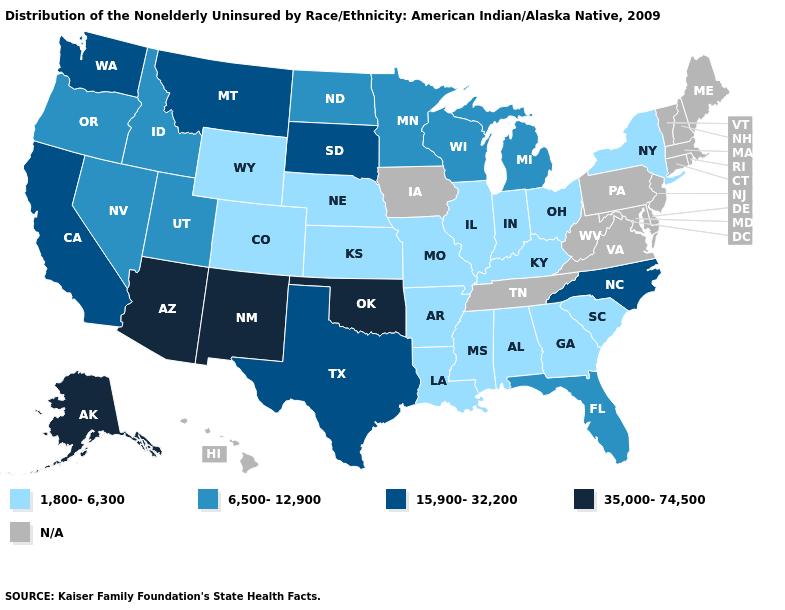Among the states that border Virginia , does Kentucky have the highest value?
Give a very brief answer. No. Name the states that have a value in the range 15,900-32,200?
Be succinct. California, Montana, North Carolina, South Dakota, Texas, Washington. Name the states that have a value in the range 15,900-32,200?
Be succinct. California, Montana, North Carolina, South Dakota, Texas, Washington. Among the states that border South Dakota , which have the lowest value?
Keep it brief. Nebraska, Wyoming. What is the value of Louisiana?
Quick response, please. 1,800-6,300. What is the value of Arizona?
Keep it brief. 35,000-74,500. What is the lowest value in the USA?
Write a very short answer. 1,800-6,300. Does the map have missing data?
Answer briefly. Yes. Name the states that have a value in the range 35,000-74,500?
Give a very brief answer. Alaska, Arizona, New Mexico, Oklahoma. Name the states that have a value in the range 35,000-74,500?
Answer briefly. Alaska, Arizona, New Mexico, Oklahoma. What is the value of Delaware?
Short answer required. N/A. Which states have the lowest value in the USA?
Give a very brief answer. Alabama, Arkansas, Colorado, Georgia, Illinois, Indiana, Kansas, Kentucky, Louisiana, Mississippi, Missouri, Nebraska, New York, Ohio, South Carolina, Wyoming. Name the states that have a value in the range 1,800-6,300?
Write a very short answer. Alabama, Arkansas, Colorado, Georgia, Illinois, Indiana, Kansas, Kentucky, Louisiana, Mississippi, Missouri, Nebraska, New York, Ohio, South Carolina, Wyoming. 